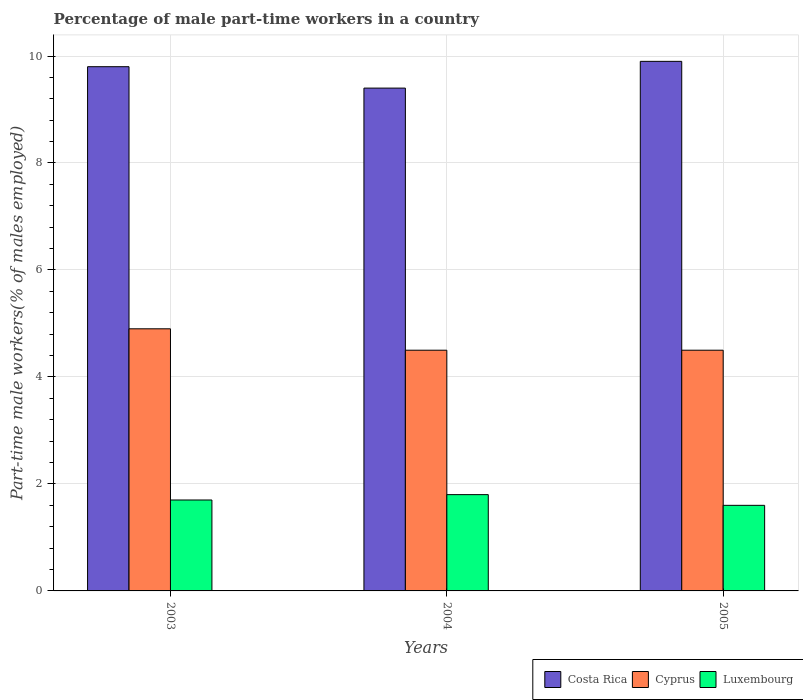Are the number of bars per tick equal to the number of legend labels?
Offer a very short reply. Yes. Are the number of bars on each tick of the X-axis equal?
Provide a succinct answer. Yes. In how many cases, is the number of bars for a given year not equal to the number of legend labels?
Make the answer very short. 0. What is the percentage of male part-time workers in Cyprus in 2003?
Ensure brevity in your answer.  4.9. Across all years, what is the maximum percentage of male part-time workers in Cyprus?
Provide a succinct answer. 4.9. Across all years, what is the minimum percentage of male part-time workers in Luxembourg?
Offer a terse response. 1.6. What is the total percentage of male part-time workers in Luxembourg in the graph?
Offer a very short reply. 5.1. What is the difference between the percentage of male part-time workers in Luxembourg in 2004 and that in 2005?
Your response must be concise. 0.2. What is the difference between the percentage of male part-time workers in Costa Rica in 2003 and the percentage of male part-time workers in Luxembourg in 2005?
Your answer should be very brief. 8.2. What is the average percentage of male part-time workers in Costa Rica per year?
Make the answer very short. 9.7. In the year 2004, what is the difference between the percentage of male part-time workers in Cyprus and percentage of male part-time workers in Costa Rica?
Your answer should be compact. -4.9. In how many years, is the percentage of male part-time workers in Luxembourg greater than 5.2 %?
Make the answer very short. 0. What is the difference between the highest and the second highest percentage of male part-time workers in Luxembourg?
Your response must be concise. 0.1. What is the difference between the highest and the lowest percentage of male part-time workers in Costa Rica?
Provide a short and direct response. 0.5. What does the 2nd bar from the right in 2004 represents?
Keep it short and to the point. Cyprus. What is the difference between two consecutive major ticks on the Y-axis?
Your response must be concise. 2. Are the values on the major ticks of Y-axis written in scientific E-notation?
Give a very brief answer. No. Does the graph contain any zero values?
Ensure brevity in your answer.  No. Does the graph contain grids?
Your answer should be compact. Yes. How many legend labels are there?
Offer a terse response. 3. What is the title of the graph?
Keep it short and to the point. Percentage of male part-time workers in a country. What is the label or title of the X-axis?
Provide a succinct answer. Years. What is the label or title of the Y-axis?
Your response must be concise. Part-time male workers(% of males employed). What is the Part-time male workers(% of males employed) of Costa Rica in 2003?
Make the answer very short. 9.8. What is the Part-time male workers(% of males employed) of Cyprus in 2003?
Offer a terse response. 4.9. What is the Part-time male workers(% of males employed) in Luxembourg in 2003?
Ensure brevity in your answer.  1.7. What is the Part-time male workers(% of males employed) of Costa Rica in 2004?
Keep it short and to the point. 9.4. What is the Part-time male workers(% of males employed) in Cyprus in 2004?
Your answer should be compact. 4.5. What is the Part-time male workers(% of males employed) in Luxembourg in 2004?
Your answer should be very brief. 1.8. What is the Part-time male workers(% of males employed) of Costa Rica in 2005?
Make the answer very short. 9.9. What is the Part-time male workers(% of males employed) of Cyprus in 2005?
Offer a terse response. 4.5. What is the Part-time male workers(% of males employed) of Luxembourg in 2005?
Provide a short and direct response. 1.6. Across all years, what is the maximum Part-time male workers(% of males employed) in Costa Rica?
Provide a succinct answer. 9.9. Across all years, what is the maximum Part-time male workers(% of males employed) of Cyprus?
Your answer should be very brief. 4.9. Across all years, what is the maximum Part-time male workers(% of males employed) of Luxembourg?
Your answer should be compact. 1.8. Across all years, what is the minimum Part-time male workers(% of males employed) in Costa Rica?
Your answer should be very brief. 9.4. Across all years, what is the minimum Part-time male workers(% of males employed) of Cyprus?
Your answer should be very brief. 4.5. Across all years, what is the minimum Part-time male workers(% of males employed) of Luxembourg?
Offer a terse response. 1.6. What is the total Part-time male workers(% of males employed) of Costa Rica in the graph?
Provide a succinct answer. 29.1. What is the total Part-time male workers(% of males employed) of Cyprus in the graph?
Give a very brief answer. 13.9. What is the difference between the Part-time male workers(% of males employed) in Cyprus in 2003 and that in 2004?
Offer a terse response. 0.4. What is the difference between the Part-time male workers(% of males employed) of Luxembourg in 2003 and that in 2004?
Offer a terse response. -0.1. What is the difference between the Part-time male workers(% of males employed) of Costa Rica in 2003 and that in 2005?
Keep it short and to the point. -0.1. What is the difference between the Part-time male workers(% of males employed) in Cyprus in 2003 and that in 2005?
Your response must be concise. 0.4. What is the difference between the Part-time male workers(% of males employed) in Luxembourg in 2003 and that in 2005?
Your answer should be very brief. 0.1. What is the difference between the Part-time male workers(% of males employed) in Costa Rica in 2003 and the Part-time male workers(% of males employed) in Cyprus in 2004?
Make the answer very short. 5.3. What is the difference between the Part-time male workers(% of males employed) in Costa Rica in 2003 and the Part-time male workers(% of males employed) in Cyprus in 2005?
Offer a terse response. 5.3. What is the difference between the Part-time male workers(% of males employed) of Costa Rica in 2003 and the Part-time male workers(% of males employed) of Luxembourg in 2005?
Ensure brevity in your answer.  8.2. What is the difference between the Part-time male workers(% of males employed) in Costa Rica in 2004 and the Part-time male workers(% of males employed) in Cyprus in 2005?
Your answer should be compact. 4.9. What is the difference between the Part-time male workers(% of males employed) in Costa Rica in 2004 and the Part-time male workers(% of males employed) in Luxembourg in 2005?
Your response must be concise. 7.8. What is the difference between the Part-time male workers(% of males employed) in Cyprus in 2004 and the Part-time male workers(% of males employed) in Luxembourg in 2005?
Provide a succinct answer. 2.9. What is the average Part-time male workers(% of males employed) in Cyprus per year?
Your answer should be compact. 4.63. What is the average Part-time male workers(% of males employed) in Luxembourg per year?
Your response must be concise. 1.7. In the year 2003, what is the difference between the Part-time male workers(% of males employed) in Costa Rica and Part-time male workers(% of males employed) in Cyprus?
Provide a succinct answer. 4.9. In the year 2003, what is the difference between the Part-time male workers(% of males employed) of Costa Rica and Part-time male workers(% of males employed) of Luxembourg?
Provide a short and direct response. 8.1. In the year 2003, what is the difference between the Part-time male workers(% of males employed) in Cyprus and Part-time male workers(% of males employed) in Luxembourg?
Your response must be concise. 3.2. In the year 2004, what is the difference between the Part-time male workers(% of males employed) in Costa Rica and Part-time male workers(% of males employed) in Luxembourg?
Give a very brief answer. 7.6. In the year 2004, what is the difference between the Part-time male workers(% of males employed) in Cyprus and Part-time male workers(% of males employed) in Luxembourg?
Give a very brief answer. 2.7. In the year 2005, what is the difference between the Part-time male workers(% of males employed) of Costa Rica and Part-time male workers(% of males employed) of Cyprus?
Provide a succinct answer. 5.4. In the year 2005, what is the difference between the Part-time male workers(% of males employed) of Cyprus and Part-time male workers(% of males employed) of Luxembourg?
Offer a terse response. 2.9. What is the ratio of the Part-time male workers(% of males employed) in Costa Rica in 2003 to that in 2004?
Offer a very short reply. 1.04. What is the ratio of the Part-time male workers(% of males employed) of Cyprus in 2003 to that in 2004?
Give a very brief answer. 1.09. What is the ratio of the Part-time male workers(% of males employed) of Luxembourg in 2003 to that in 2004?
Give a very brief answer. 0.94. What is the ratio of the Part-time male workers(% of males employed) of Costa Rica in 2003 to that in 2005?
Your response must be concise. 0.99. What is the ratio of the Part-time male workers(% of males employed) in Cyprus in 2003 to that in 2005?
Keep it short and to the point. 1.09. What is the ratio of the Part-time male workers(% of males employed) of Luxembourg in 2003 to that in 2005?
Your answer should be very brief. 1.06. What is the ratio of the Part-time male workers(% of males employed) of Costa Rica in 2004 to that in 2005?
Give a very brief answer. 0.95. What is the ratio of the Part-time male workers(% of males employed) in Cyprus in 2004 to that in 2005?
Give a very brief answer. 1. What is the difference between the highest and the second highest Part-time male workers(% of males employed) in Costa Rica?
Keep it short and to the point. 0.1. What is the difference between the highest and the second highest Part-time male workers(% of males employed) in Luxembourg?
Give a very brief answer. 0.1. 